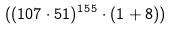Convert formula to latex. <formula><loc_0><loc_0><loc_500><loc_500>( ( 1 0 7 \cdot 5 1 ) ^ { 1 5 5 } \cdot ( 1 + 8 ) )</formula> 